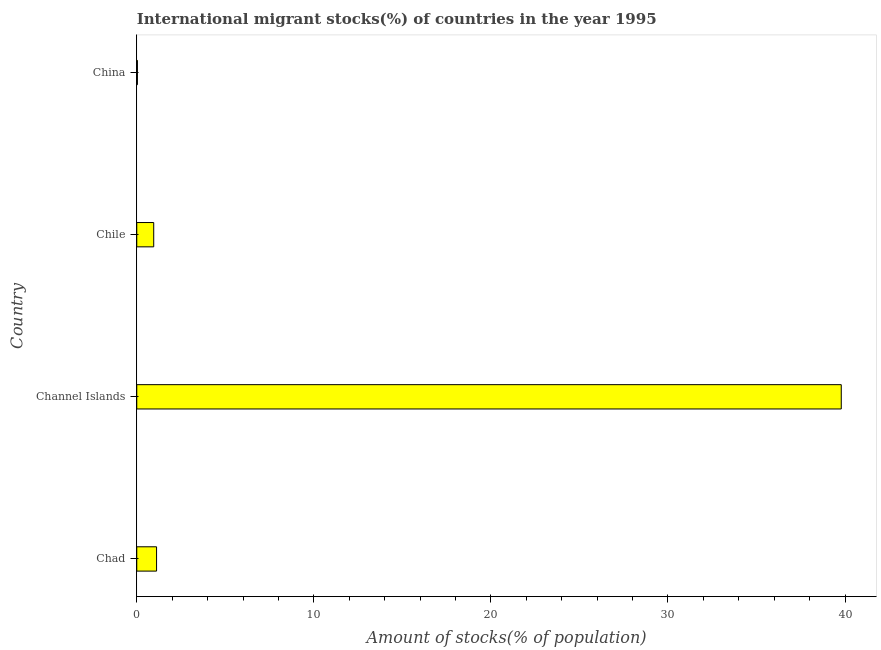Does the graph contain any zero values?
Make the answer very short. No. What is the title of the graph?
Your answer should be compact. International migrant stocks(%) of countries in the year 1995. What is the label or title of the X-axis?
Your answer should be compact. Amount of stocks(% of population). What is the number of international migrant stocks in Channel Islands?
Ensure brevity in your answer.  39.79. Across all countries, what is the maximum number of international migrant stocks?
Provide a succinct answer. 39.79. Across all countries, what is the minimum number of international migrant stocks?
Provide a succinct answer. 0.04. In which country was the number of international migrant stocks maximum?
Offer a terse response. Channel Islands. What is the sum of the number of international migrant stocks?
Provide a short and direct response. 41.9. What is the difference between the number of international migrant stocks in Chad and China?
Keep it short and to the point. 1.08. What is the average number of international migrant stocks per country?
Offer a very short reply. 10.47. What is the median number of international migrant stocks?
Make the answer very short. 1.04. In how many countries, is the number of international migrant stocks greater than 30 %?
Keep it short and to the point. 1. What is the ratio of the number of international migrant stocks in Chad to that in China?
Offer a very short reply. 30.8. Is the number of international migrant stocks in Chad less than that in Chile?
Keep it short and to the point. No. What is the difference between the highest and the second highest number of international migrant stocks?
Make the answer very short. 38.67. What is the difference between the highest and the lowest number of international migrant stocks?
Keep it short and to the point. 39.75. In how many countries, is the number of international migrant stocks greater than the average number of international migrant stocks taken over all countries?
Offer a very short reply. 1. What is the difference between two consecutive major ticks on the X-axis?
Your response must be concise. 10. Are the values on the major ticks of X-axis written in scientific E-notation?
Keep it short and to the point. No. What is the Amount of stocks(% of population) of Chad?
Your response must be concise. 1.12. What is the Amount of stocks(% of population) of Channel Islands?
Your answer should be compact. 39.79. What is the Amount of stocks(% of population) in Chile?
Provide a succinct answer. 0.96. What is the Amount of stocks(% of population) in China?
Keep it short and to the point. 0.04. What is the difference between the Amount of stocks(% of population) in Chad and Channel Islands?
Offer a terse response. -38.67. What is the difference between the Amount of stocks(% of population) in Chad and Chile?
Your response must be concise. 0.16. What is the difference between the Amount of stocks(% of population) in Chad and China?
Provide a succinct answer. 1.08. What is the difference between the Amount of stocks(% of population) in Channel Islands and Chile?
Your response must be concise. 38.83. What is the difference between the Amount of stocks(% of population) in Channel Islands and China?
Offer a terse response. 39.75. What is the difference between the Amount of stocks(% of population) in Chile and China?
Your answer should be very brief. 0.92. What is the ratio of the Amount of stocks(% of population) in Chad to that in Channel Islands?
Your response must be concise. 0.03. What is the ratio of the Amount of stocks(% of population) in Chad to that in Chile?
Offer a terse response. 1.17. What is the ratio of the Amount of stocks(% of population) in Chad to that in China?
Provide a succinct answer. 30.8. What is the ratio of the Amount of stocks(% of population) in Channel Islands to that in Chile?
Your answer should be compact. 41.57. What is the ratio of the Amount of stocks(% of population) in Channel Islands to that in China?
Give a very brief answer. 1096.29. What is the ratio of the Amount of stocks(% of population) in Chile to that in China?
Make the answer very short. 26.37. 